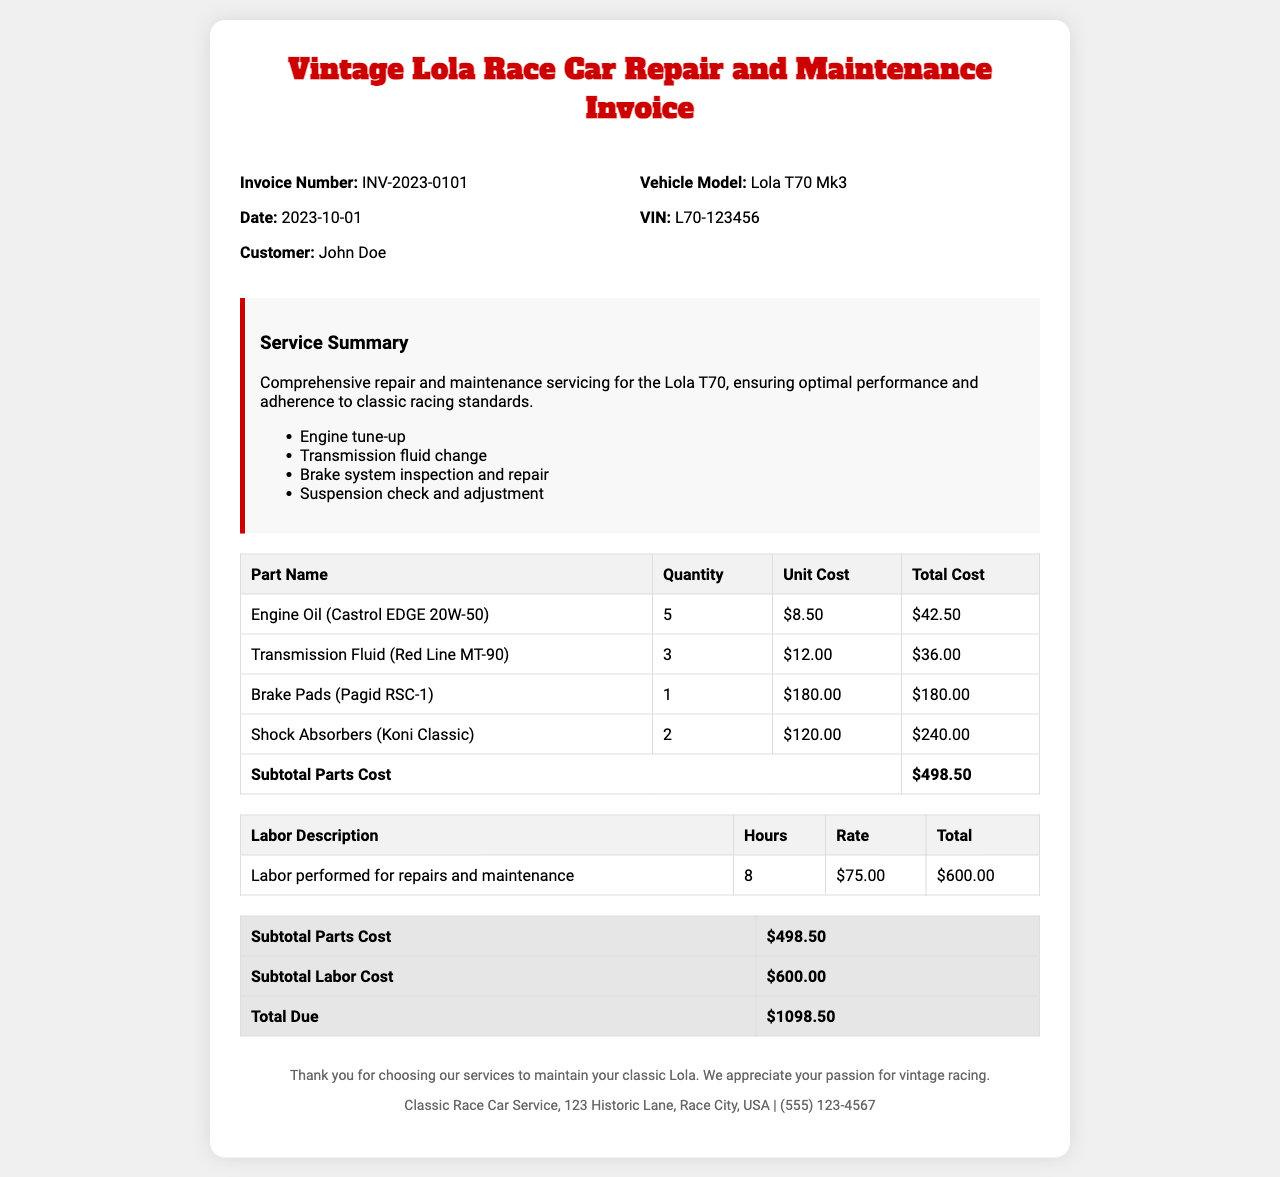What is the invoice number? The invoice number is mentioned in the document under the invoice details section.
Answer: INV-2023-0101 What is the date of the invoice? The date is specified in the invoice details section, indicating when the invoice was issued.
Answer: 2023-10-01 Who is the customer? The customer's name is stated in the invoice details section.
Answer: John Doe What is the total cost for parts? The total cost for parts is listed in the subtotal section of the parts table.
Answer: $498.50 How many hours of labor were performed? The number of labor hours is recorded in the labor cost table under the hours column.
Answer: 8 What is the rate per hour for labor? The rate per hour of labor is detailed in the labor cost table.
Answer: $75.00 What is the total due amount? The total due is the sum of all costs presented in the invoice and is indicated in the total section.
Answer: $1098.50 What vehicle model is listed in the document? The vehicle model is shown in the invoice details section under the vehicle information.
Answer: Lola T70 Mk3 What parts were used for the engine maintenance? The parts used for engine maintenance are listed in the parts table under part names.
Answer: Engine Oil (Castrol EDGE 20W-50), Transmission Fluid (Red Line MT-90) 